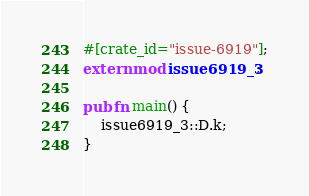<code> <loc_0><loc_0><loc_500><loc_500><_Rust_>#[crate_id="issue-6919"];
extern mod issue6919_3;

pub fn main() {
    issue6919_3::D.k;
}

</code> 